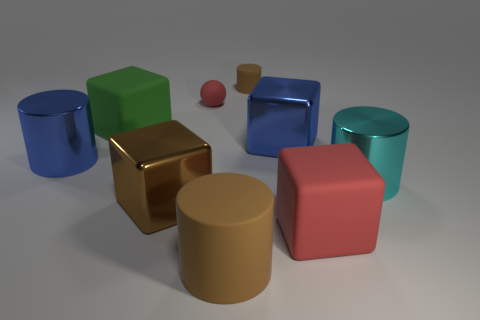Could you describe the lighting used in this scene? The scene is lit with a soft, diffused light that seems to be coming from the upper left, given the placement of the shadows on the ground. There isn't a harsh direct light source visible, which would create sharp shadows; instead, the shadows are soft-edged, suggesting an indirect source of light, creating a calm and evenly-lit scene.  How would this image be different if it were rendered in a photorealistic style? If the image were rendered in a photorealistic style, it would include more nuanced details such as texture variations, imperfections on the surfaces of the objects, more complex lighting with reflections, refractions, and perhaps some environmental context like a room setting or landscape. These elements would add depth and realism, giving viewers a sense of how these objects might exist in the real world. 